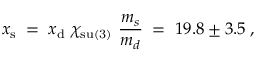<formula> <loc_0><loc_0><loc_500><loc_500>x _ { s } \, = \, x _ { d } \chi _ { s u ( 3 ) } \frac { m _ { s } } { m _ { d } } \, = \, 1 9 . 8 \pm 3 . 5 \, ,</formula> 